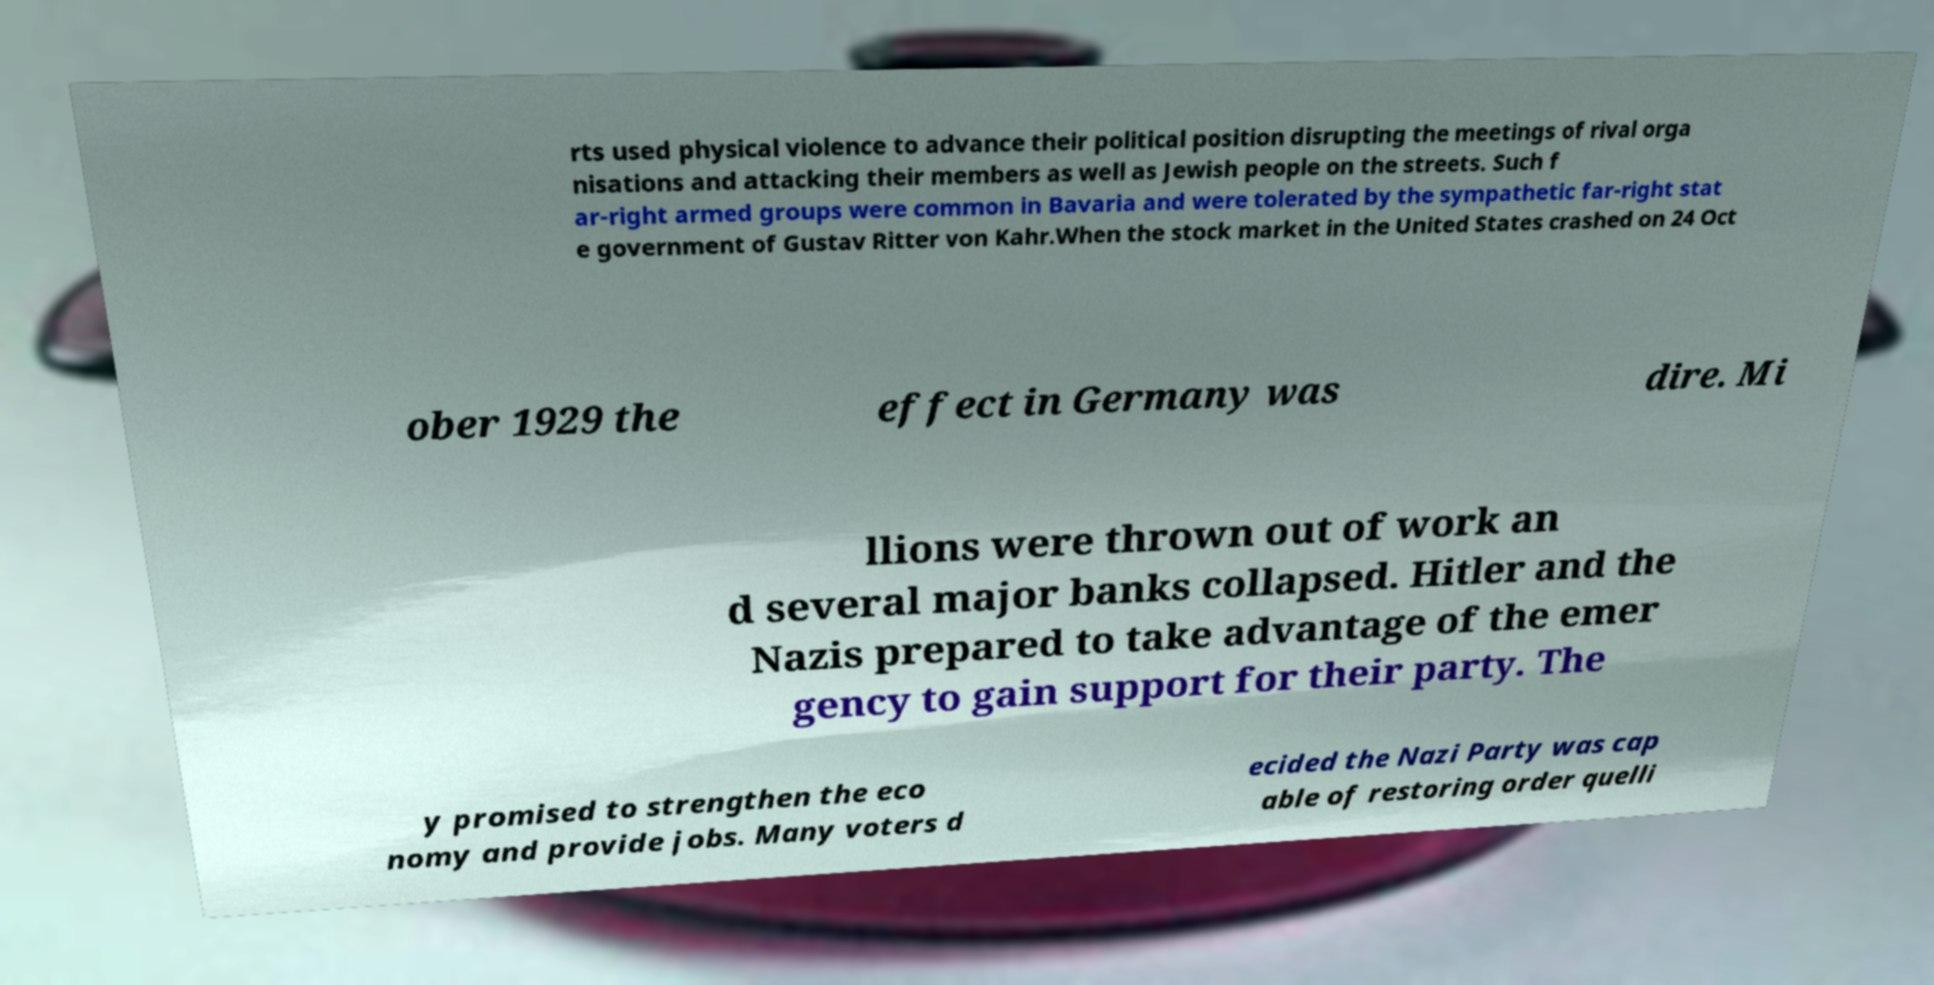There's text embedded in this image that I need extracted. Can you transcribe it verbatim? rts used physical violence to advance their political position disrupting the meetings of rival orga nisations and attacking their members as well as Jewish people on the streets. Such f ar-right armed groups were common in Bavaria and were tolerated by the sympathetic far-right stat e government of Gustav Ritter von Kahr.When the stock market in the United States crashed on 24 Oct ober 1929 the effect in Germany was dire. Mi llions were thrown out of work an d several major banks collapsed. Hitler and the Nazis prepared to take advantage of the emer gency to gain support for their party. The y promised to strengthen the eco nomy and provide jobs. Many voters d ecided the Nazi Party was cap able of restoring order quelli 